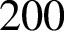<formula> <loc_0><loc_0><loc_500><loc_500>2 0 0</formula> 